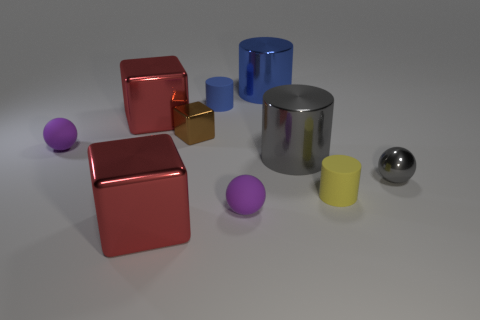Is the surface upon which the objects are placed perfectly flat or does it have some texture? The surface appears to be predominantly flat with a subtle texture that's hard to discern unless viewed up close. The matte quality suggests that light is diffusely reflected, hinting at a slight texture. 